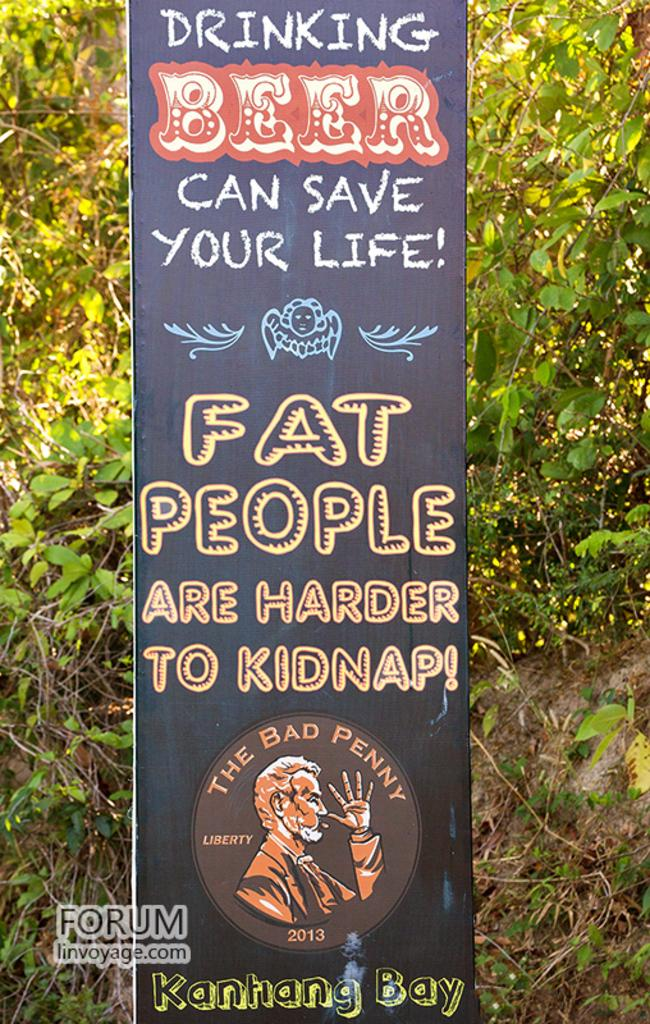What is the main subject of the advertisement in the image? The advertisement is about a cafe. What can be seen behind the advertisement board? There are trees visible behind the advertisement board. Where is the advertisement located? The advertisement board is in the image. What is the title of the self-help book being advertised on the board? There is no self-help book being advertised on the board; it is an advertisement for a cafe. 